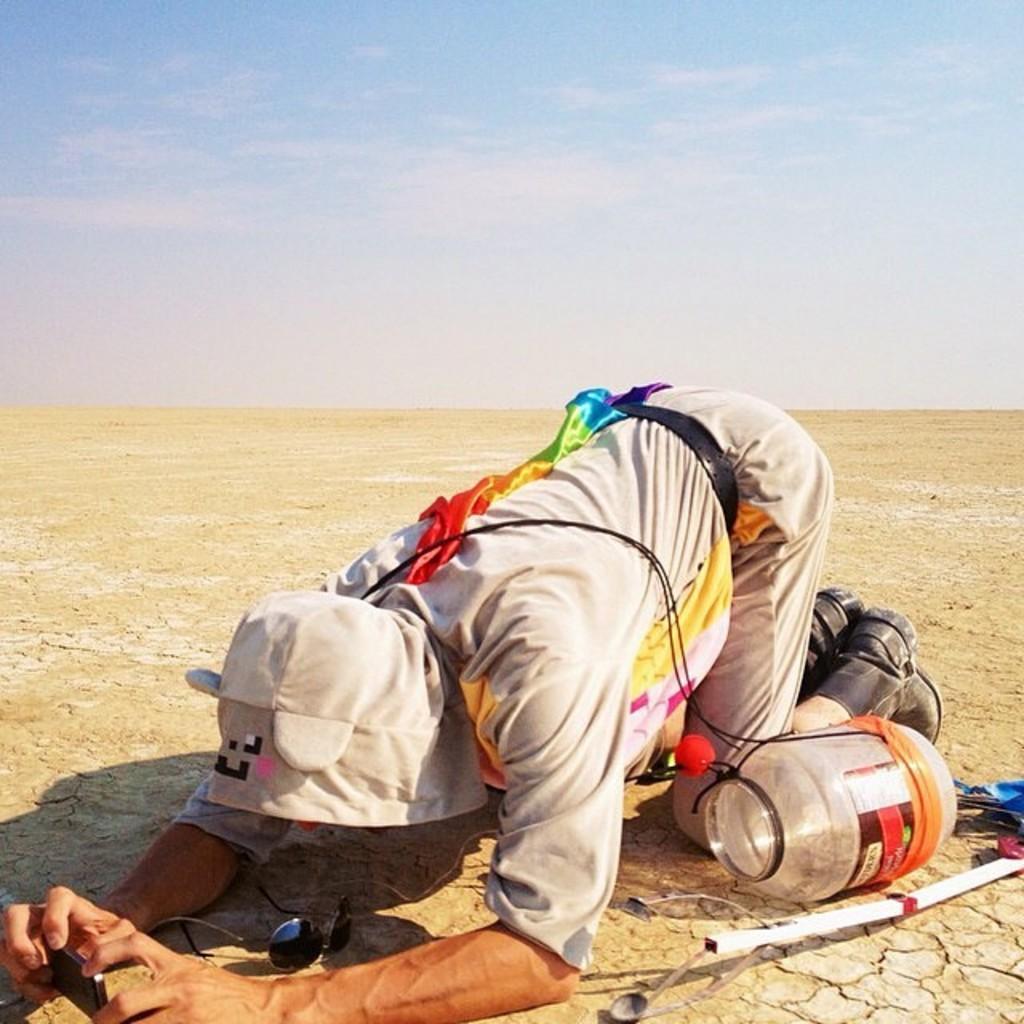In one or two sentences, can you explain what this image depicts? In this picture we can see a person here, behind him there is a jar, we can see goggles here, the person is holding a mobile phone, we can see the sky at the top of the picture. 